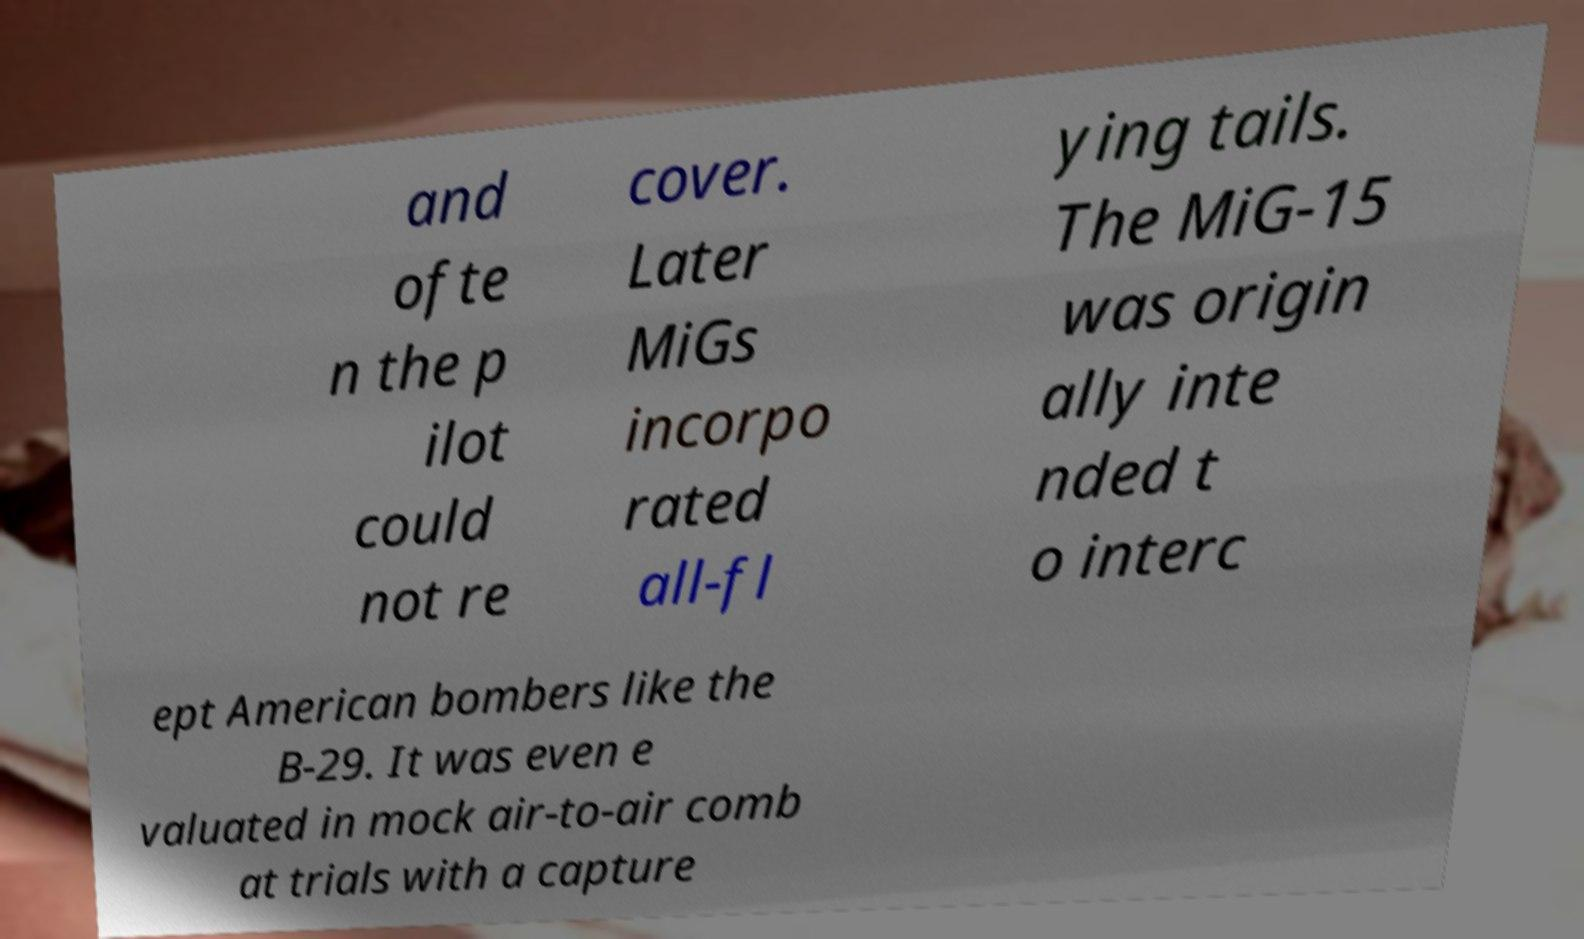Can you read and provide the text displayed in the image?This photo seems to have some interesting text. Can you extract and type it out for me? and ofte n the p ilot could not re cover. Later MiGs incorpo rated all-fl ying tails. The MiG-15 was origin ally inte nded t o interc ept American bombers like the B-29. It was even e valuated in mock air-to-air comb at trials with a capture 